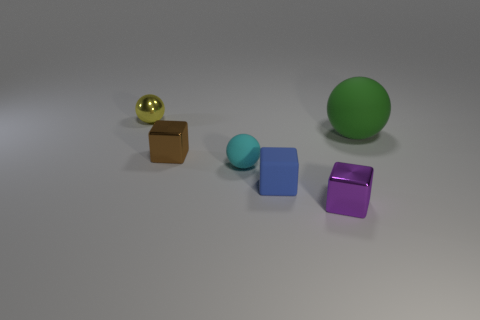There is a block that is to the left of the cyan sphere; is it the same size as the cyan object?
Provide a short and direct response. Yes. Are there fewer small purple metallic things than brown matte things?
Your answer should be compact. No. Is there another cyan ball made of the same material as the big ball?
Give a very brief answer. Yes. There is a rubber object behind the cyan ball; what is its shape?
Your answer should be compact. Sphere. Is the number of small shiny spheres to the right of the cyan rubber object less than the number of small brown objects?
Give a very brief answer. Yes. The tiny cube that is the same material as the brown object is what color?
Make the answer very short. Purple. What size is the matte object on the right side of the blue cube?
Keep it short and to the point. Large. Is the material of the purple thing the same as the cyan thing?
Your answer should be very brief. No. Is there a green rubber thing on the right side of the ball that is in front of the small metal block to the left of the small purple cube?
Your answer should be very brief. Yes. The big rubber sphere has what color?
Provide a succinct answer. Green. 